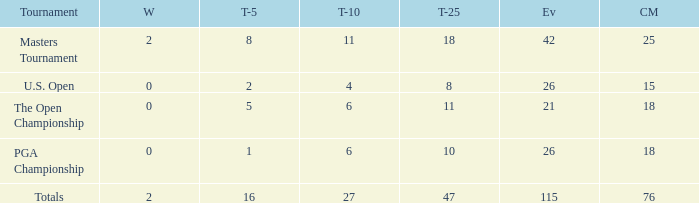What is the average Top-10 with a greater than 11 Top-25 and a less than 2 wins? None. Can you parse all the data within this table? {'header': ['Tournament', 'W', 'T-5', 'T-10', 'T-25', 'Ev', 'CM'], 'rows': [['Masters Tournament', '2', '8', '11', '18', '42', '25'], ['U.S. Open', '0', '2', '4', '8', '26', '15'], ['The Open Championship', '0', '5', '6', '11', '21', '18'], ['PGA Championship', '0', '1', '6', '10', '26', '18'], ['Totals', '2', '16', '27', '47', '115', '76']]} 